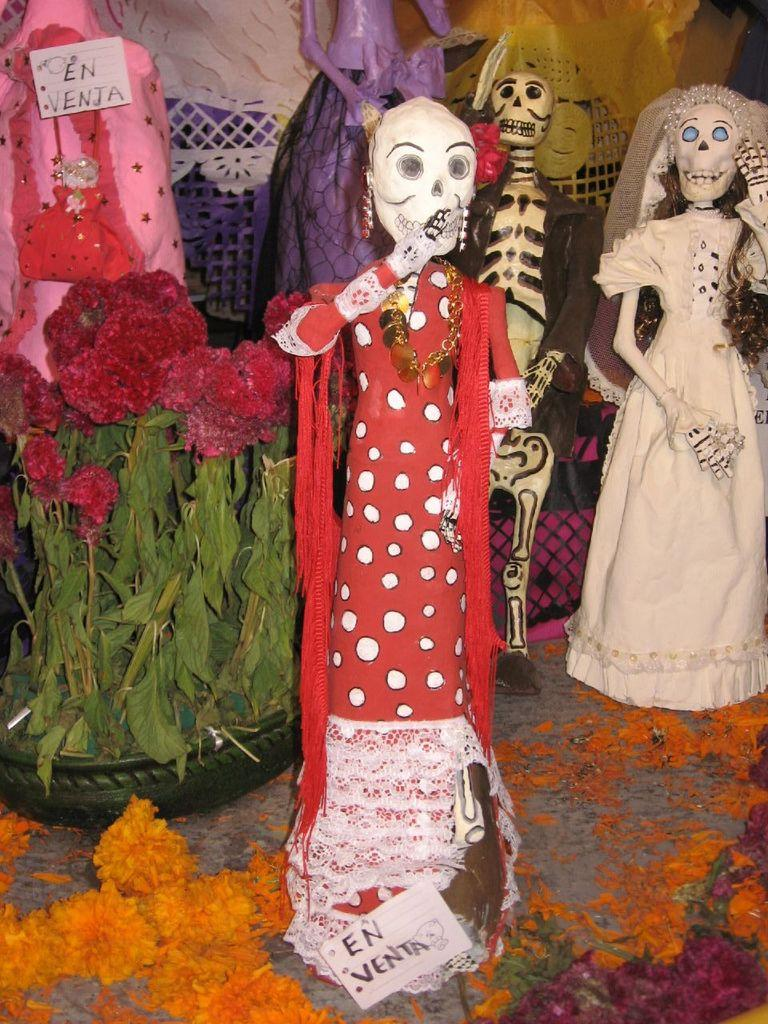What can be seen in the image that resembles playthings? There is a group of toys in the image. How are the toys dressed in the image? The toys are wearing costumes. What type of vegetation is present in the image? There are plants and flowers in the image. What is the purpose of the board at the bottom of the image? There is a board at the bottom of the image with text on it. What type of oatmeal is being served at the meeting in the image? There is no meeting or oatmeal present in the image; it features a group of toys wearing costumes, plants, flowers, and a board with text. 